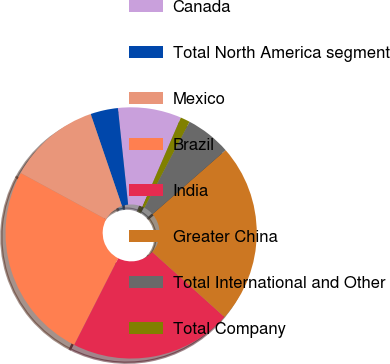Convert chart. <chart><loc_0><loc_0><loc_500><loc_500><pie_chart><fcel>Canada<fcel>Total North America segment<fcel>Mexico<fcel>Brazil<fcel>India<fcel>Greater China<fcel>Total International and Other<fcel>Total Company<nl><fcel>8.16%<fcel>3.54%<fcel>11.87%<fcel>25.43%<fcel>20.81%<fcel>23.12%<fcel>5.85%<fcel>1.22%<nl></chart> 